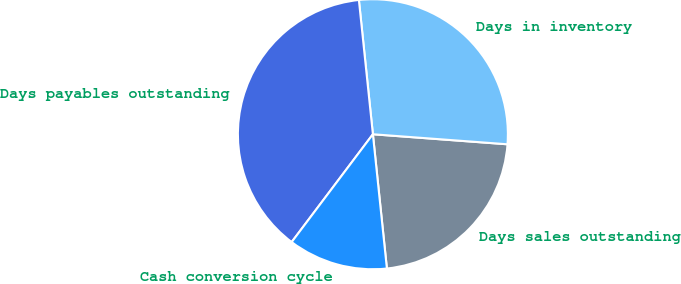Convert chart to OTSL. <chart><loc_0><loc_0><loc_500><loc_500><pie_chart><fcel>Days sales outstanding<fcel>Days in inventory<fcel>Days payables outstanding<fcel>Cash conversion cycle<nl><fcel>22.16%<fcel>27.84%<fcel>38.07%<fcel>11.93%<nl></chart> 